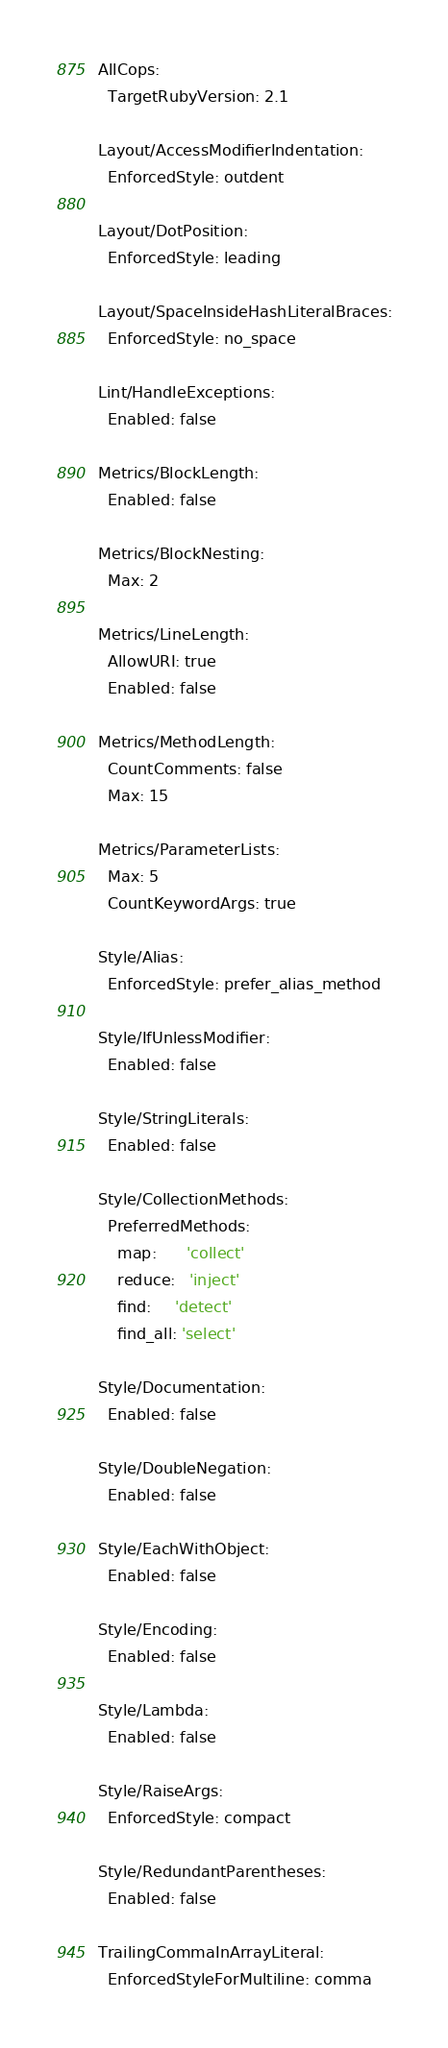Convert code to text. <code><loc_0><loc_0><loc_500><loc_500><_YAML_>AllCops:
  TargetRubyVersion: 2.1

Layout/AccessModifierIndentation:
  EnforcedStyle: outdent

Layout/DotPosition:
  EnforcedStyle: leading

Layout/SpaceInsideHashLiteralBraces:
  EnforcedStyle: no_space

Lint/HandleExceptions:
  Enabled: false

Metrics/BlockLength:
  Enabled: false

Metrics/BlockNesting:
  Max: 2

Metrics/LineLength:
  AllowURI: true
  Enabled: false

Metrics/MethodLength:
  CountComments: false
  Max: 15

Metrics/ParameterLists:
  Max: 5
  CountKeywordArgs: true

Style/Alias:
  EnforcedStyle: prefer_alias_method

Style/IfUnlessModifier:
  Enabled: false

Style/StringLiterals:
  Enabled: false

Style/CollectionMethods:
  PreferredMethods:
    map:      'collect'
    reduce:   'inject'
    find:     'detect'
    find_all: 'select'

Style/Documentation:
  Enabled: false

Style/DoubleNegation:
  Enabled: false

Style/EachWithObject:
  Enabled: false

Style/Encoding:
  Enabled: false

Style/Lambda:
  Enabled: false

Style/RaiseArgs:
  EnforcedStyle: compact

Style/RedundantParentheses:
  Enabled: false

TrailingCommaInArrayLiteral:
  EnforcedStyleForMultiline: comma
</code> 